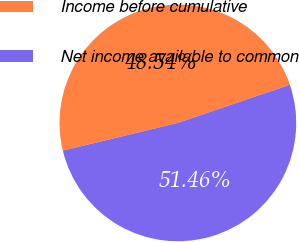<chart> <loc_0><loc_0><loc_500><loc_500><pie_chart><fcel>Income before cumulative<fcel>Net income available to common<nl><fcel>48.54%<fcel>51.46%<nl></chart> 